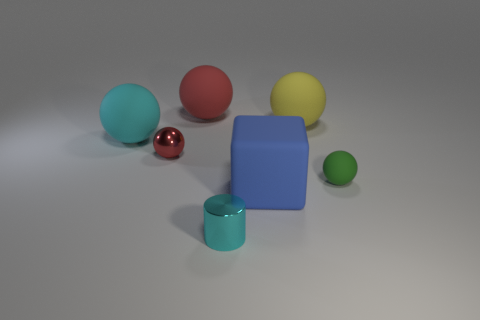Could you describe the lighting and shadows in the image? The image has soft, diffused lighting, creating gentle shadows on the left side of the objects, suggesting a light source to the top right. 